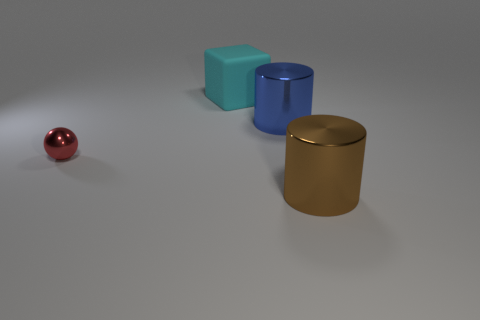Add 1 big blue cubes. How many objects exist? 5 Subtract all blocks. How many objects are left? 3 Subtract all small red blocks. Subtract all cyan matte blocks. How many objects are left? 3 Add 3 brown metallic cylinders. How many brown metallic cylinders are left? 4 Add 3 tiny objects. How many tiny objects exist? 4 Subtract 0 yellow cylinders. How many objects are left? 4 